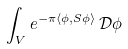<formula> <loc_0><loc_0><loc_500><loc_500>\int _ { V } e ^ { - \pi \langle \phi , S \phi \rangle } \, { \mathcal { D } } \phi</formula> 